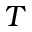<formula> <loc_0><loc_0><loc_500><loc_500>T</formula> 